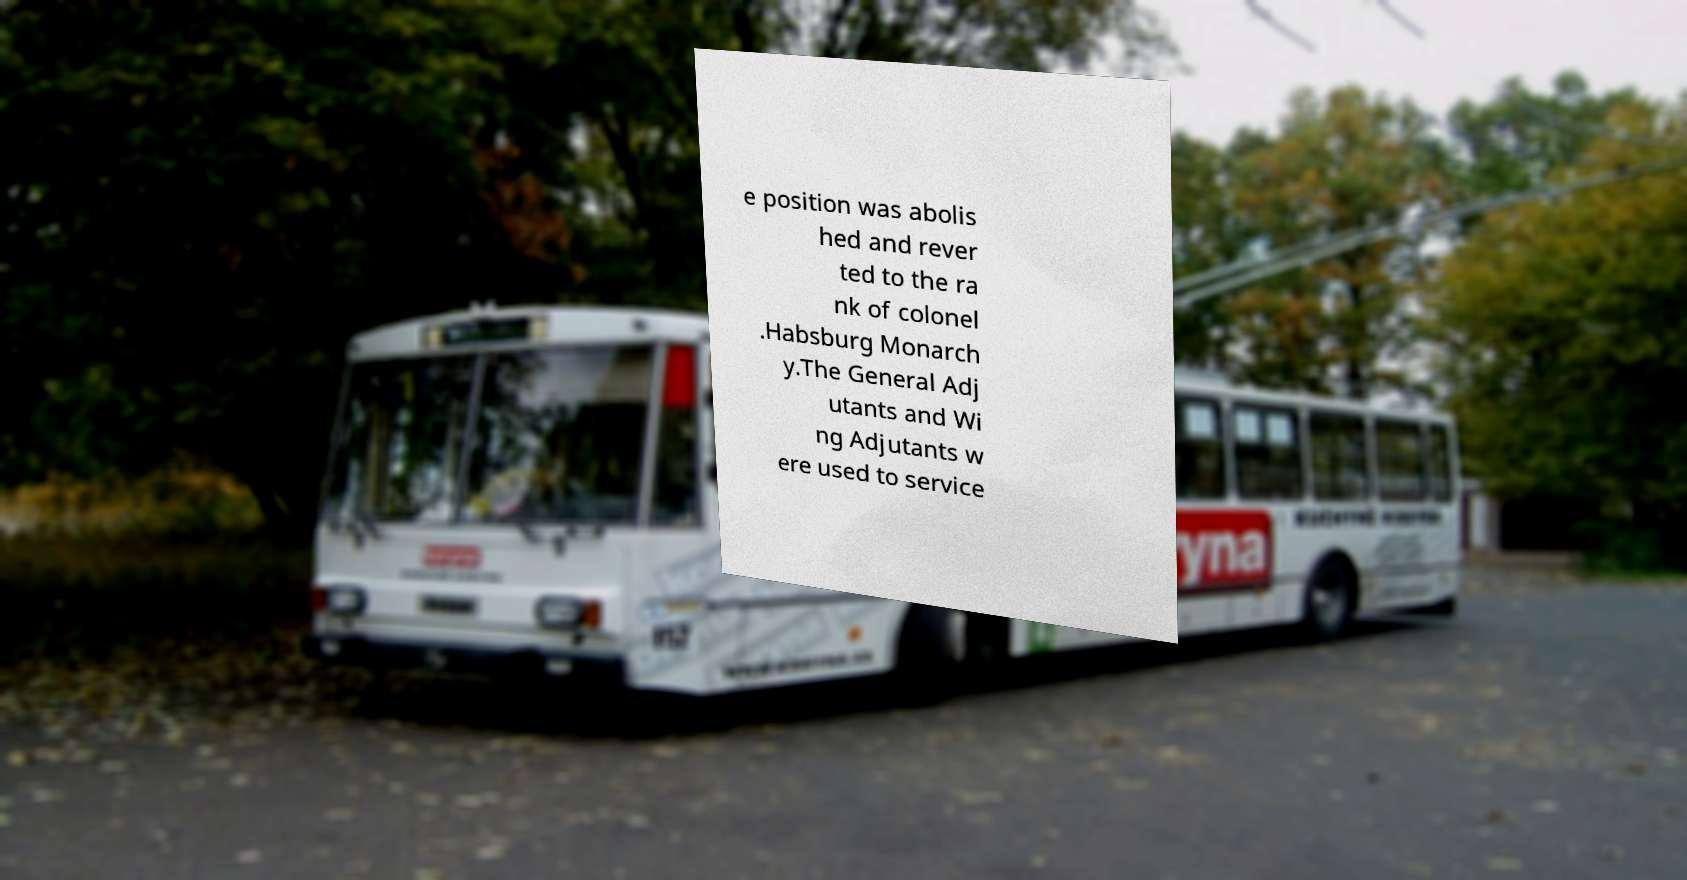What messages or text are displayed in this image? I need them in a readable, typed format. e position was abolis hed and rever ted to the ra nk of colonel .Habsburg Monarch y.The General Adj utants and Wi ng Adjutants w ere used to service 